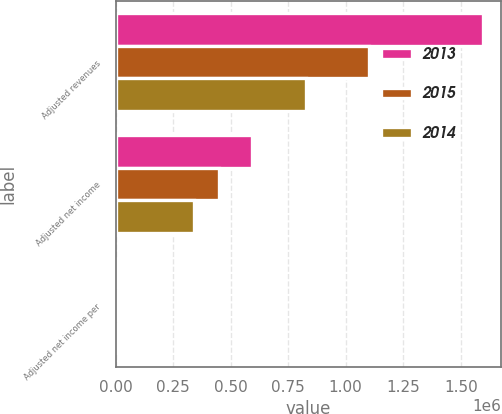Convert chart. <chart><loc_0><loc_0><loc_500><loc_500><stacked_bar_chart><ecel><fcel>Adjusted revenues<fcel>Adjusted net income<fcel>Adjusted net income per<nl><fcel>2013<fcel>1.59461e+06<fcel>592625<fcel>6.3<nl><fcel>2015<fcel>1.10314e+06<fcel>447670<fcel>5.15<nl><fcel>2014<fcel>827028<fcel>342680<fcel>4.05<nl></chart> 